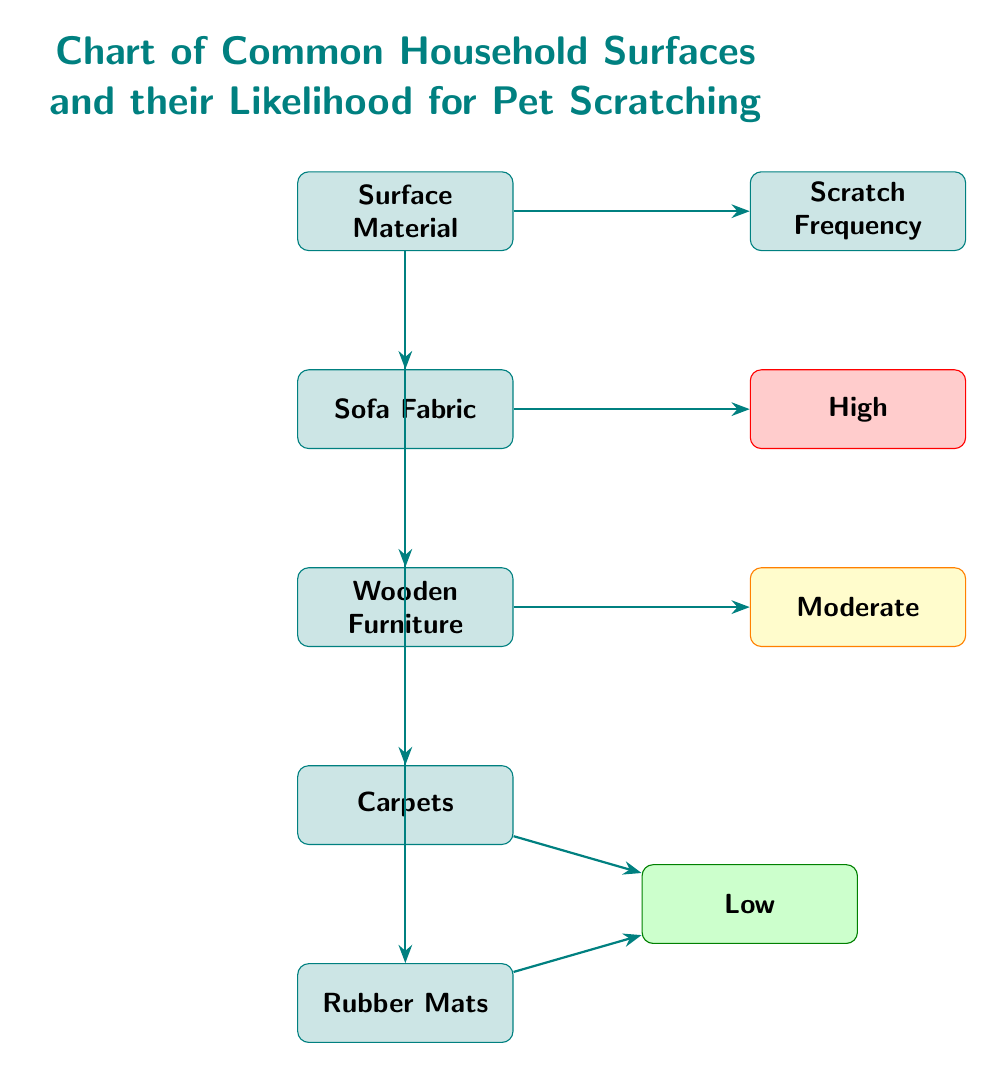What surface material is associated with high scratch frequency? The diagram shows that "Sofa Fabric" is directly connected to the "High" scratch frequency node, indicating that it has a high likelihood for scratching.
Answer: Sofa Fabric Which surfaces are categorized as having low scratch frequency? The diagram indicates that both "Carpets" and "Rubber Mats" are connected to the "Low" scratch frequency node, marking them as having low likelihood for scratching.
Answer: Carpets, Rubber Mats What is the scratch frequency for Wooden Furniture? The diagram connects "Wooden Furniture" to the "Moderate" scratch frequency node, meaning its likelihood for scratching is moderate.
Answer: Moderate How many surface materials are listed in the diagram? By counting the distinct nodes under the "Surface Material" category, there are four materials: "Sofa Fabric," "Wooden Furniture," "Carpets," and "Rubber Mats." Thus, the total count is four.
Answer: 4 Which surface material has the highest likelihood for scratching? The arrow from "Sofa Fabric" points to the "High" scratch frequency category, indicating that this surface material has the highest likelihood for scratching compared to others shown.
Answer: High Does Wooden Furniture have a higher or lower scratch frequency than Carpets? The connection of "Wooden Furniture" to the "Moderate" category and "Carpets" to the "Low" category indicates that Wooden Furniture has a higher scratch frequency than Carpets.
Answer: Higher What are the categories of scratch frequency indicated in the diagram? The diagram shows three categories of scratch frequency: "High," "Moderate," and "Low," represented by distinct nodes to differentiate their likelihood.
Answer: High, Moderate, Low Which surface appears to be the least likely to be scratched? Based on the connections, "Rubber Mats" and "Carpets" both point to the "Low" scratch frequency category, indicating they are the least likely to be scratched; however, the question aims for the least specific surface.
Answer: Rubber Mats 